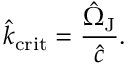<formula> <loc_0><loc_0><loc_500><loc_500>\hat { k } _ { c r i t } = \frac { \hat { \Omega } _ { J } } { \hat { c } } .</formula> 